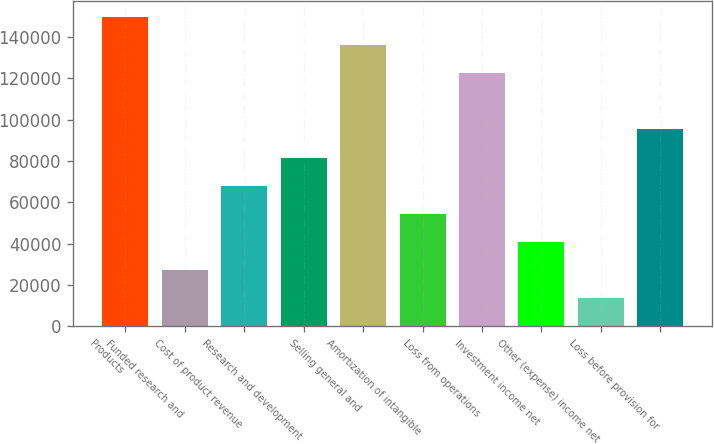Convert chart. <chart><loc_0><loc_0><loc_500><loc_500><bar_chart><fcel>Products<fcel>Funded research and<fcel>Cost of product revenue<fcel>Research and development<fcel>Selling general and<fcel>Amortization of intangible<fcel>Loss from operations<fcel>Investment income net<fcel>Other (expense) income net<fcel>Loss before provision for<nl><fcel>149801<fcel>27237.4<fcel>68092<fcel>81710.2<fcel>136183<fcel>54473.8<fcel>122565<fcel>40855.6<fcel>13619.2<fcel>95328.4<nl></chart> 